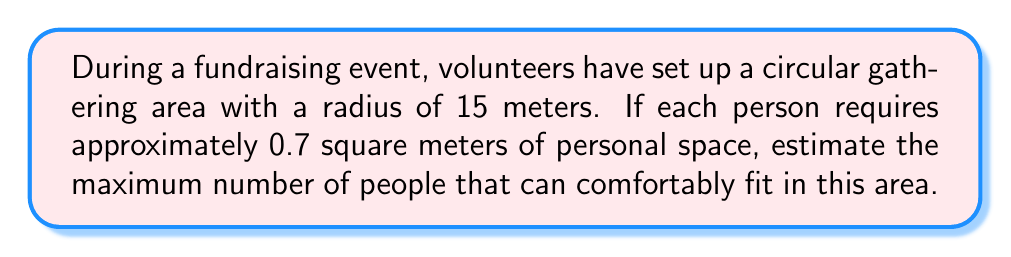Provide a solution to this math problem. To solve this problem, we'll follow these steps:

1. Calculate the area of the circular gathering space:
   The area of a circle is given by the formula $A = \pi r^2$
   where $r$ is the radius.
   
   $A = \pi \cdot 15^2 = 225\pi \approx 706.86$ square meters

2. Determine the space required per person:
   Each person needs 0.7 square meters.

3. Calculate the maximum number of people:
   Divide the total area by the space required per person.
   
   $\text{Number of people} = \frac{\text{Total area}}{\text{Space per person}}$
   
   $\text{Number of people} = \frac{706.86}{0.7} \approx 1009.80$

4. Round down to the nearest whole number:
   Since we can't have a fraction of a person, we round down to 1009.

Note: In practice, you may want to leave some space for movement and comfort, so the actual capacity might be slightly less than this theoretical maximum.
Answer: 1009 people 